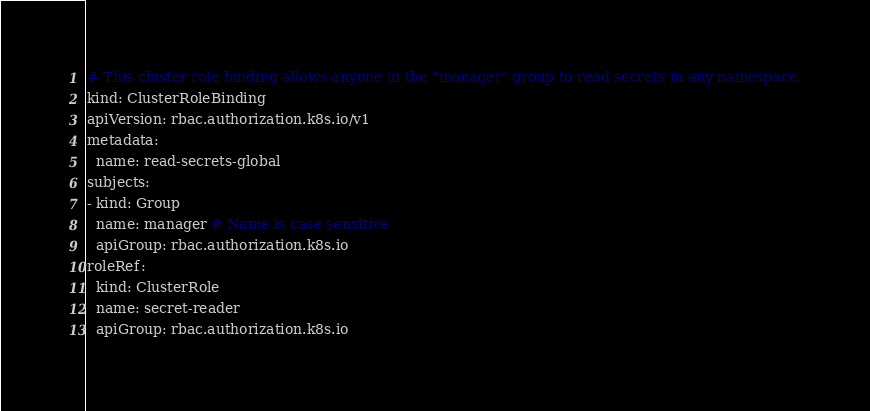Convert code to text. <code><loc_0><loc_0><loc_500><loc_500><_YAML_># This cluster role binding allows anyone in the "manager" group to read secrets in any namespace.
kind: ClusterRoleBinding
apiVersion: rbac.authorization.k8s.io/v1
metadata:
  name: read-secrets-global
subjects:
- kind: Group
  name: manager # Name is case sensitive
  apiGroup: rbac.authorization.k8s.io
roleRef:
  kind: ClusterRole
  name: secret-reader
  apiGroup: rbac.authorization.k8s.io</code> 